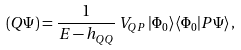Convert formula to latex. <formula><loc_0><loc_0><loc_500><loc_500>( Q \Psi ) = \frac { 1 } { E - h _ { Q Q } } \, V _ { Q P } \, | \Phi _ { 0 } \rangle \langle \Phi _ { 0 } | P \Psi \rangle \, ,</formula> 